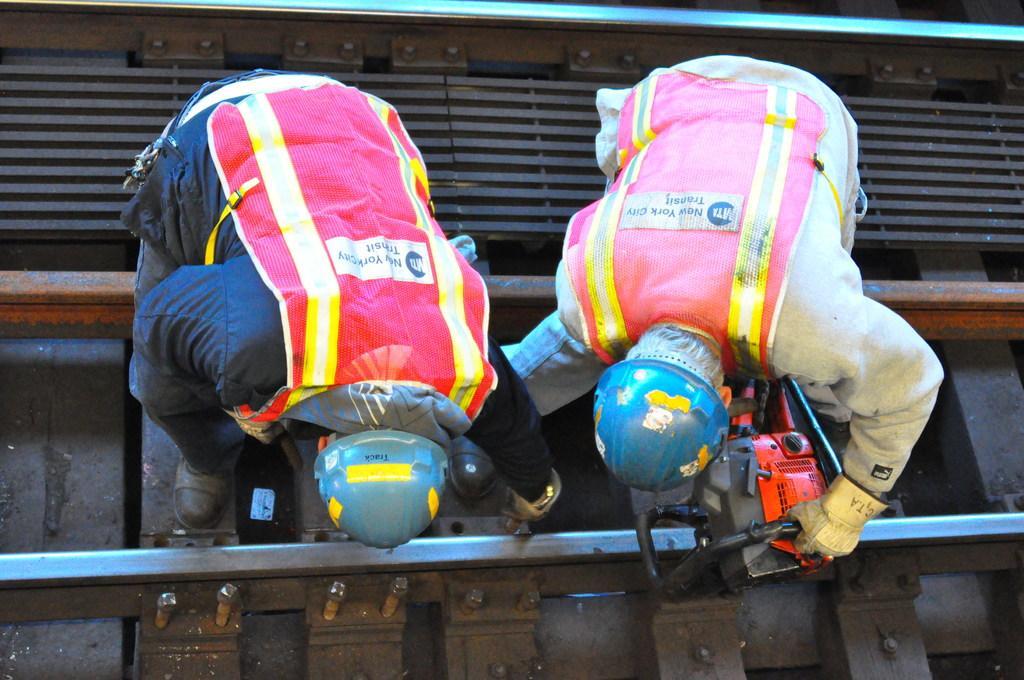How would you summarize this image in a sentence or two? In this image there are persons working on the railway track. 